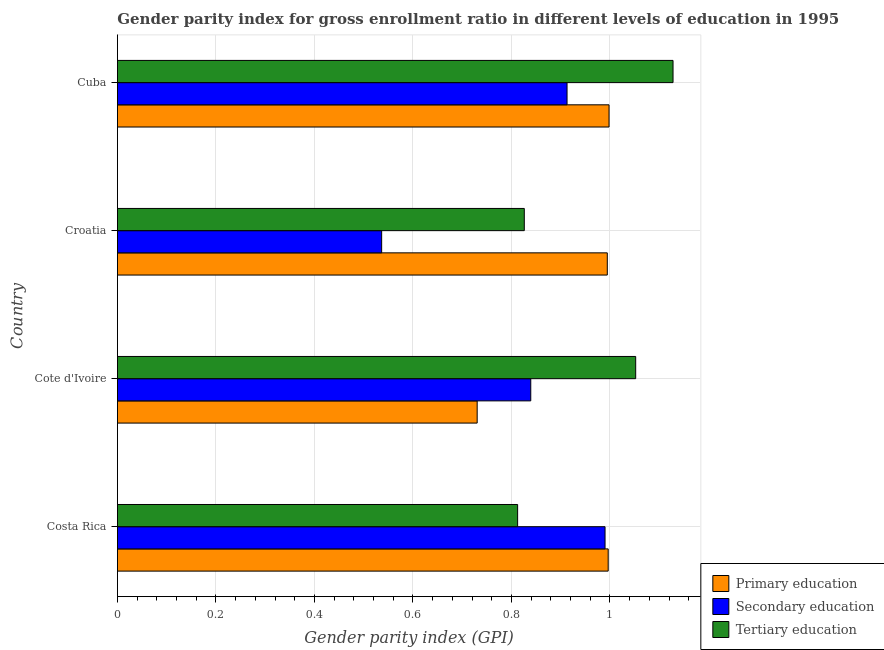How many different coloured bars are there?
Offer a terse response. 3. How many bars are there on the 2nd tick from the bottom?
Provide a short and direct response. 3. What is the label of the 2nd group of bars from the top?
Offer a terse response. Croatia. Across all countries, what is the maximum gender parity index in tertiary education?
Provide a succinct answer. 1.13. Across all countries, what is the minimum gender parity index in primary education?
Make the answer very short. 0.73. In which country was the gender parity index in secondary education maximum?
Make the answer very short. Costa Rica. In which country was the gender parity index in primary education minimum?
Provide a short and direct response. Cote d'Ivoire. What is the total gender parity index in secondary education in the graph?
Keep it short and to the point. 3.28. What is the difference between the gender parity index in tertiary education in Croatia and that in Cuba?
Your answer should be very brief. -0.3. What is the difference between the gender parity index in tertiary education in Croatia and the gender parity index in secondary education in Cote d'Ivoire?
Your answer should be compact. -0.01. What is the average gender parity index in tertiary education per country?
Offer a terse response. 0.95. What is the difference between the gender parity index in secondary education and gender parity index in tertiary education in Croatia?
Offer a terse response. -0.29. What is the ratio of the gender parity index in secondary education in Cote d'Ivoire to that in Croatia?
Your response must be concise. 1.56. Is the difference between the gender parity index in tertiary education in Costa Rica and Cuba greater than the difference between the gender parity index in primary education in Costa Rica and Cuba?
Keep it short and to the point. No. What is the difference between the highest and the second highest gender parity index in tertiary education?
Make the answer very short. 0.08. What is the difference between the highest and the lowest gender parity index in tertiary education?
Your answer should be compact. 0.32. What does the 3rd bar from the bottom in Costa Rica represents?
Provide a succinct answer. Tertiary education. Does the graph contain any zero values?
Keep it short and to the point. No. Where does the legend appear in the graph?
Give a very brief answer. Bottom right. How are the legend labels stacked?
Provide a succinct answer. Vertical. What is the title of the graph?
Provide a short and direct response. Gender parity index for gross enrollment ratio in different levels of education in 1995. What is the label or title of the X-axis?
Provide a succinct answer. Gender parity index (GPI). What is the label or title of the Y-axis?
Make the answer very short. Country. What is the Gender parity index (GPI) in Primary education in Costa Rica?
Provide a succinct answer. 1. What is the Gender parity index (GPI) of Secondary education in Costa Rica?
Your answer should be compact. 0.99. What is the Gender parity index (GPI) of Tertiary education in Costa Rica?
Ensure brevity in your answer.  0.81. What is the Gender parity index (GPI) of Primary education in Cote d'Ivoire?
Your answer should be very brief. 0.73. What is the Gender parity index (GPI) in Secondary education in Cote d'Ivoire?
Offer a terse response. 0.84. What is the Gender parity index (GPI) of Tertiary education in Cote d'Ivoire?
Your answer should be very brief. 1.05. What is the Gender parity index (GPI) in Primary education in Croatia?
Your response must be concise. 0.99. What is the Gender parity index (GPI) of Secondary education in Croatia?
Offer a very short reply. 0.54. What is the Gender parity index (GPI) in Tertiary education in Croatia?
Your answer should be compact. 0.83. What is the Gender parity index (GPI) in Primary education in Cuba?
Offer a very short reply. 1. What is the Gender parity index (GPI) of Secondary education in Cuba?
Keep it short and to the point. 0.91. What is the Gender parity index (GPI) in Tertiary education in Cuba?
Keep it short and to the point. 1.13. Across all countries, what is the maximum Gender parity index (GPI) of Primary education?
Offer a very short reply. 1. Across all countries, what is the maximum Gender parity index (GPI) in Secondary education?
Ensure brevity in your answer.  0.99. Across all countries, what is the maximum Gender parity index (GPI) in Tertiary education?
Your response must be concise. 1.13. Across all countries, what is the minimum Gender parity index (GPI) in Primary education?
Your answer should be very brief. 0.73. Across all countries, what is the minimum Gender parity index (GPI) in Secondary education?
Provide a succinct answer. 0.54. Across all countries, what is the minimum Gender parity index (GPI) in Tertiary education?
Your response must be concise. 0.81. What is the total Gender parity index (GPI) of Primary education in the graph?
Your answer should be very brief. 3.72. What is the total Gender parity index (GPI) of Secondary education in the graph?
Provide a succinct answer. 3.28. What is the total Gender parity index (GPI) in Tertiary education in the graph?
Provide a succinct answer. 3.82. What is the difference between the Gender parity index (GPI) of Primary education in Costa Rica and that in Cote d'Ivoire?
Provide a short and direct response. 0.27. What is the difference between the Gender parity index (GPI) of Secondary education in Costa Rica and that in Cote d'Ivoire?
Make the answer very short. 0.15. What is the difference between the Gender parity index (GPI) in Tertiary education in Costa Rica and that in Cote d'Ivoire?
Your answer should be very brief. -0.24. What is the difference between the Gender parity index (GPI) in Primary education in Costa Rica and that in Croatia?
Offer a very short reply. 0. What is the difference between the Gender parity index (GPI) in Secondary education in Costa Rica and that in Croatia?
Give a very brief answer. 0.45. What is the difference between the Gender parity index (GPI) in Tertiary education in Costa Rica and that in Croatia?
Give a very brief answer. -0.01. What is the difference between the Gender parity index (GPI) in Primary education in Costa Rica and that in Cuba?
Your answer should be compact. -0. What is the difference between the Gender parity index (GPI) of Secondary education in Costa Rica and that in Cuba?
Ensure brevity in your answer.  0.08. What is the difference between the Gender parity index (GPI) of Tertiary education in Costa Rica and that in Cuba?
Provide a short and direct response. -0.32. What is the difference between the Gender parity index (GPI) in Primary education in Cote d'Ivoire and that in Croatia?
Ensure brevity in your answer.  -0.26. What is the difference between the Gender parity index (GPI) in Secondary education in Cote d'Ivoire and that in Croatia?
Ensure brevity in your answer.  0.3. What is the difference between the Gender parity index (GPI) of Tertiary education in Cote d'Ivoire and that in Croatia?
Give a very brief answer. 0.23. What is the difference between the Gender parity index (GPI) of Primary education in Cote d'Ivoire and that in Cuba?
Your response must be concise. -0.27. What is the difference between the Gender parity index (GPI) in Secondary education in Cote d'Ivoire and that in Cuba?
Give a very brief answer. -0.07. What is the difference between the Gender parity index (GPI) in Tertiary education in Cote d'Ivoire and that in Cuba?
Your answer should be very brief. -0.08. What is the difference between the Gender parity index (GPI) in Primary education in Croatia and that in Cuba?
Keep it short and to the point. -0. What is the difference between the Gender parity index (GPI) in Secondary education in Croatia and that in Cuba?
Your response must be concise. -0.38. What is the difference between the Gender parity index (GPI) of Tertiary education in Croatia and that in Cuba?
Ensure brevity in your answer.  -0.3. What is the difference between the Gender parity index (GPI) of Primary education in Costa Rica and the Gender parity index (GPI) of Secondary education in Cote d'Ivoire?
Provide a succinct answer. 0.16. What is the difference between the Gender parity index (GPI) in Primary education in Costa Rica and the Gender parity index (GPI) in Tertiary education in Cote d'Ivoire?
Make the answer very short. -0.06. What is the difference between the Gender parity index (GPI) of Secondary education in Costa Rica and the Gender parity index (GPI) of Tertiary education in Cote d'Ivoire?
Keep it short and to the point. -0.06. What is the difference between the Gender parity index (GPI) of Primary education in Costa Rica and the Gender parity index (GPI) of Secondary education in Croatia?
Ensure brevity in your answer.  0.46. What is the difference between the Gender parity index (GPI) in Primary education in Costa Rica and the Gender parity index (GPI) in Tertiary education in Croatia?
Your response must be concise. 0.17. What is the difference between the Gender parity index (GPI) of Secondary education in Costa Rica and the Gender parity index (GPI) of Tertiary education in Croatia?
Ensure brevity in your answer.  0.16. What is the difference between the Gender parity index (GPI) in Primary education in Costa Rica and the Gender parity index (GPI) in Secondary education in Cuba?
Keep it short and to the point. 0.08. What is the difference between the Gender parity index (GPI) in Primary education in Costa Rica and the Gender parity index (GPI) in Tertiary education in Cuba?
Offer a very short reply. -0.13. What is the difference between the Gender parity index (GPI) in Secondary education in Costa Rica and the Gender parity index (GPI) in Tertiary education in Cuba?
Make the answer very short. -0.14. What is the difference between the Gender parity index (GPI) of Primary education in Cote d'Ivoire and the Gender parity index (GPI) of Secondary education in Croatia?
Offer a very short reply. 0.19. What is the difference between the Gender parity index (GPI) of Primary education in Cote d'Ivoire and the Gender parity index (GPI) of Tertiary education in Croatia?
Your answer should be very brief. -0.1. What is the difference between the Gender parity index (GPI) of Secondary education in Cote d'Ivoire and the Gender parity index (GPI) of Tertiary education in Croatia?
Your answer should be very brief. 0.01. What is the difference between the Gender parity index (GPI) of Primary education in Cote d'Ivoire and the Gender parity index (GPI) of Secondary education in Cuba?
Provide a succinct answer. -0.18. What is the difference between the Gender parity index (GPI) of Primary education in Cote d'Ivoire and the Gender parity index (GPI) of Tertiary education in Cuba?
Offer a terse response. -0.4. What is the difference between the Gender parity index (GPI) of Secondary education in Cote d'Ivoire and the Gender parity index (GPI) of Tertiary education in Cuba?
Your answer should be compact. -0.29. What is the difference between the Gender parity index (GPI) in Primary education in Croatia and the Gender parity index (GPI) in Secondary education in Cuba?
Offer a very short reply. 0.08. What is the difference between the Gender parity index (GPI) of Primary education in Croatia and the Gender parity index (GPI) of Tertiary education in Cuba?
Make the answer very short. -0.13. What is the difference between the Gender parity index (GPI) of Secondary education in Croatia and the Gender parity index (GPI) of Tertiary education in Cuba?
Give a very brief answer. -0.59. What is the average Gender parity index (GPI) in Primary education per country?
Ensure brevity in your answer.  0.93. What is the average Gender parity index (GPI) in Secondary education per country?
Offer a terse response. 0.82. What is the average Gender parity index (GPI) of Tertiary education per country?
Ensure brevity in your answer.  0.95. What is the difference between the Gender parity index (GPI) of Primary education and Gender parity index (GPI) of Secondary education in Costa Rica?
Make the answer very short. 0.01. What is the difference between the Gender parity index (GPI) in Primary education and Gender parity index (GPI) in Tertiary education in Costa Rica?
Your answer should be very brief. 0.18. What is the difference between the Gender parity index (GPI) in Secondary education and Gender parity index (GPI) in Tertiary education in Costa Rica?
Your response must be concise. 0.18. What is the difference between the Gender parity index (GPI) in Primary education and Gender parity index (GPI) in Secondary education in Cote d'Ivoire?
Keep it short and to the point. -0.11. What is the difference between the Gender parity index (GPI) of Primary education and Gender parity index (GPI) of Tertiary education in Cote d'Ivoire?
Your answer should be very brief. -0.32. What is the difference between the Gender parity index (GPI) in Secondary education and Gender parity index (GPI) in Tertiary education in Cote d'Ivoire?
Make the answer very short. -0.21. What is the difference between the Gender parity index (GPI) in Primary education and Gender parity index (GPI) in Secondary education in Croatia?
Offer a very short reply. 0.46. What is the difference between the Gender parity index (GPI) of Primary education and Gender parity index (GPI) of Tertiary education in Croatia?
Make the answer very short. 0.17. What is the difference between the Gender parity index (GPI) in Secondary education and Gender parity index (GPI) in Tertiary education in Croatia?
Provide a succinct answer. -0.29. What is the difference between the Gender parity index (GPI) of Primary education and Gender parity index (GPI) of Secondary education in Cuba?
Your answer should be very brief. 0.09. What is the difference between the Gender parity index (GPI) of Primary education and Gender parity index (GPI) of Tertiary education in Cuba?
Make the answer very short. -0.13. What is the difference between the Gender parity index (GPI) in Secondary education and Gender parity index (GPI) in Tertiary education in Cuba?
Offer a terse response. -0.22. What is the ratio of the Gender parity index (GPI) of Primary education in Costa Rica to that in Cote d'Ivoire?
Offer a very short reply. 1.36. What is the ratio of the Gender parity index (GPI) in Secondary education in Costa Rica to that in Cote d'Ivoire?
Keep it short and to the point. 1.18. What is the ratio of the Gender parity index (GPI) of Tertiary education in Costa Rica to that in Cote d'Ivoire?
Your response must be concise. 0.77. What is the ratio of the Gender parity index (GPI) in Primary education in Costa Rica to that in Croatia?
Keep it short and to the point. 1. What is the ratio of the Gender parity index (GPI) of Secondary education in Costa Rica to that in Croatia?
Your response must be concise. 1.85. What is the ratio of the Gender parity index (GPI) in Tertiary education in Costa Rica to that in Croatia?
Offer a terse response. 0.98. What is the ratio of the Gender parity index (GPI) of Secondary education in Costa Rica to that in Cuba?
Provide a succinct answer. 1.08. What is the ratio of the Gender parity index (GPI) of Tertiary education in Costa Rica to that in Cuba?
Make the answer very short. 0.72. What is the ratio of the Gender parity index (GPI) in Primary education in Cote d'Ivoire to that in Croatia?
Offer a terse response. 0.73. What is the ratio of the Gender parity index (GPI) in Secondary education in Cote d'Ivoire to that in Croatia?
Your answer should be very brief. 1.56. What is the ratio of the Gender parity index (GPI) of Tertiary education in Cote d'Ivoire to that in Croatia?
Your response must be concise. 1.27. What is the ratio of the Gender parity index (GPI) in Primary education in Cote d'Ivoire to that in Cuba?
Your answer should be compact. 0.73. What is the ratio of the Gender parity index (GPI) of Secondary education in Cote d'Ivoire to that in Cuba?
Provide a succinct answer. 0.92. What is the ratio of the Gender parity index (GPI) in Tertiary education in Cote d'Ivoire to that in Cuba?
Provide a succinct answer. 0.93. What is the ratio of the Gender parity index (GPI) of Secondary education in Croatia to that in Cuba?
Offer a very short reply. 0.59. What is the ratio of the Gender parity index (GPI) of Tertiary education in Croatia to that in Cuba?
Your answer should be very brief. 0.73. What is the difference between the highest and the second highest Gender parity index (GPI) in Primary education?
Your response must be concise. 0. What is the difference between the highest and the second highest Gender parity index (GPI) of Secondary education?
Keep it short and to the point. 0.08. What is the difference between the highest and the second highest Gender parity index (GPI) of Tertiary education?
Make the answer very short. 0.08. What is the difference between the highest and the lowest Gender parity index (GPI) of Primary education?
Provide a short and direct response. 0.27. What is the difference between the highest and the lowest Gender parity index (GPI) of Secondary education?
Make the answer very short. 0.45. What is the difference between the highest and the lowest Gender parity index (GPI) in Tertiary education?
Offer a terse response. 0.32. 